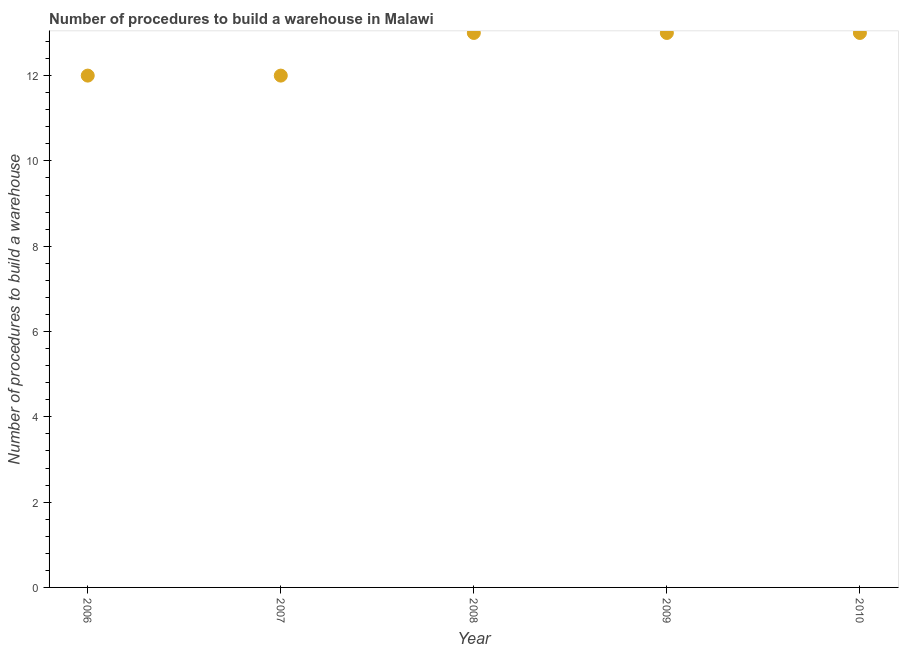What is the number of procedures to build a warehouse in 2006?
Provide a succinct answer. 12. Across all years, what is the maximum number of procedures to build a warehouse?
Give a very brief answer. 13. Across all years, what is the minimum number of procedures to build a warehouse?
Offer a terse response. 12. In which year was the number of procedures to build a warehouse maximum?
Your response must be concise. 2008. In which year was the number of procedures to build a warehouse minimum?
Give a very brief answer. 2006. What is the sum of the number of procedures to build a warehouse?
Keep it short and to the point. 63. What is the difference between the number of procedures to build a warehouse in 2007 and 2010?
Keep it short and to the point. -1. What is the median number of procedures to build a warehouse?
Your answer should be very brief. 13. In how many years, is the number of procedures to build a warehouse greater than 3.6 ?
Your answer should be very brief. 5. Do a majority of the years between 2009 and 2008 (inclusive) have number of procedures to build a warehouse greater than 2 ?
Offer a terse response. No. What is the ratio of the number of procedures to build a warehouse in 2006 to that in 2008?
Give a very brief answer. 0.92. What is the difference between the highest and the second highest number of procedures to build a warehouse?
Provide a short and direct response. 0. Is the sum of the number of procedures to build a warehouse in 2008 and 2009 greater than the maximum number of procedures to build a warehouse across all years?
Your response must be concise. Yes. What is the difference between the highest and the lowest number of procedures to build a warehouse?
Offer a very short reply. 1. In how many years, is the number of procedures to build a warehouse greater than the average number of procedures to build a warehouse taken over all years?
Offer a terse response. 3. How many years are there in the graph?
Offer a terse response. 5. What is the difference between two consecutive major ticks on the Y-axis?
Give a very brief answer. 2. Does the graph contain any zero values?
Keep it short and to the point. No. What is the title of the graph?
Your answer should be compact. Number of procedures to build a warehouse in Malawi. What is the label or title of the Y-axis?
Ensure brevity in your answer.  Number of procedures to build a warehouse. What is the Number of procedures to build a warehouse in 2009?
Make the answer very short. 13. What is the Number of procedures to build a warehouse in 2010?
Provide a short and direct response. 13. What is the difference between the Number of procedures to build a warehouse in 2006 and 2008?
Ensure brevity in your answer.  -1. What is the difference between the Number of procedures to build a warehouse in 2006 and 2010?
Provide a short and direct response. -1. What is the difference between the Number of procedures to build a warehouse in 2007 and 2008?
Make the answer very short. -1. What is the difference between the Number of procedures to build a warehouse in 2008 and 2009?
Your answer should be compact. 0. What is the difference between the Number of procedures to build a warehouse in 2009 and 2010?
Provide a short and direct response. 0. What is the ratio of the Number of procedures to build a warehouse in 2006 to that in 2007?
Offer a terse response. 1. What is the ratio of the Number of procedures to build a warehouse in 2006 to that in 2008?
Keep it short and to the point. 0.92. What is the ratio of the Number of procedures to build a warehouse in 2006 to that in 2009?
Offer a terse response. 0.92. What is the ratio of the Number of procedures to build a warehouse in 2006 to that in 2010?
Your answer should be compact. 0.92. What is the ratio of the Number of procedures to build a warehouse in 2007 to that in 2008?
Your response must be concise. 0.92. What is the ratio of the Number of procedures to build a warehouse in 2007 to that in 2009?
Offer a very short reply. 0.92. What is the ratio of the Number of procedures to build a warehouse in 2007 to that in 2010?
Provide a succinct answer. 0.92. What is the ratio of the Number of procedures to build a warehouse in 2008 to that in 2009?
Make the answer very short. 1. What is the ratio of the Number of procedures to build a warehouse in 2008 to that in 2010?
Offer a very short reply. 1. 